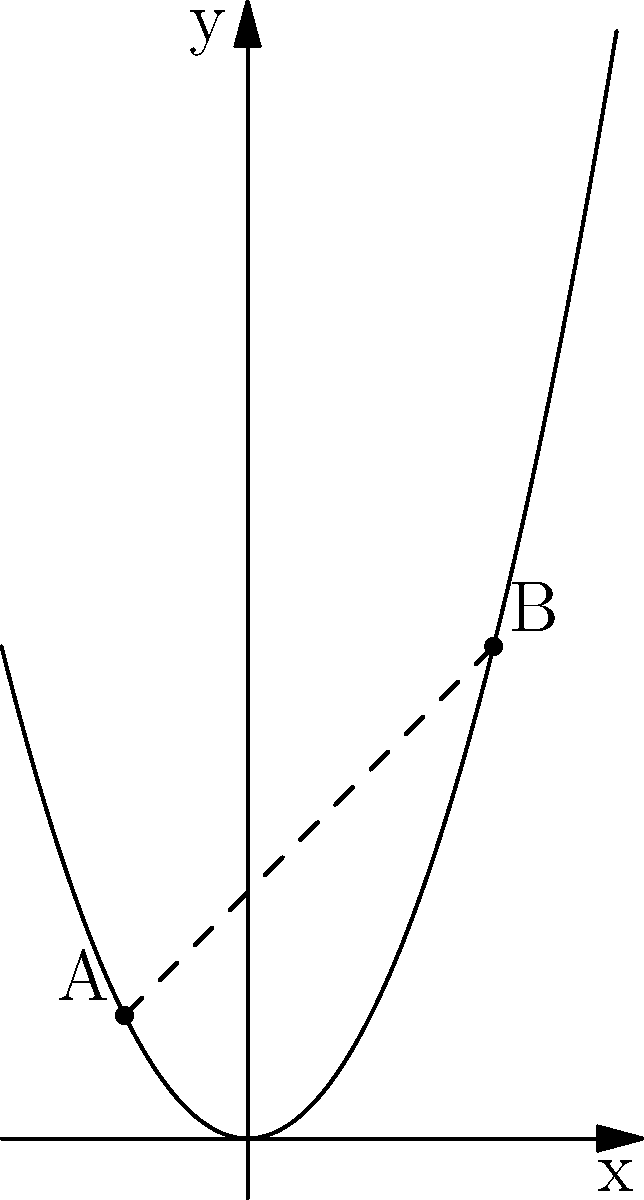A sociologist studying the distribution of religious institutions in urban areas models their locations on a coordinate plane. The parabola $y = x^2$ represents a trend line for these locations. Two significant points, A(-1, 1) and B(2, 4), represent clusters of institutions. Calculate the distance between these two points along the parabola, considering the ethical implications of religious density in urban planning. To find the distance between two points along a parabola, we need to use the arc length formula:

1) The arc length formula for a function $y = f(x)$ from $x = a$ to $x = b$ is:

   $L = \int_{a}^{b} \sqrt{1 + [f'(x)]^2} dx$

2) In this case, $f(x) = x^2$, so $f'(x) = 2x$

3) Substituting into the formula:

   $L = \int_{-1}^{2} \sqrt{1 + (2x)^2} dx$

4) Simplify under the square root:

   $L = \int_{-1}^{2} \sqrt{1 + 4x^2} dx$

5) This integral doesn't have an elementary antiderivative. We need to use numerical integration or special functions.

6) Using numerical integration, we get:

   $L \approx 3.8284$

This result shows that the distance between religious clusters is about 3.8284 units along the parabola, which could inform urban planning decisions regarding the distribution of ethical resources and community centers, independent of religious affiliation.
Answer: $3.8284$ units 